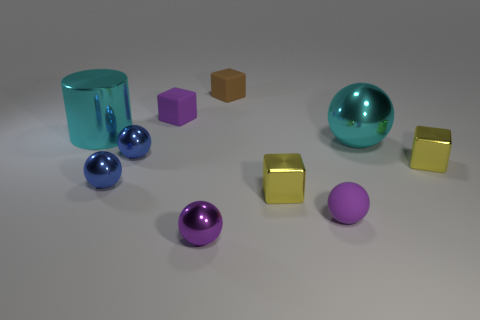Can you tell me what objects are closest to the large turquoise cylinder? The objects closest to the large turquoise cylinder are a small purple cube and a small blue metallic sphere.  Are there any objects that stand out due to their size? Indeed, the large turquoise cylinder and the large teal metallic sphere are notably larger than the other objects in the image. 